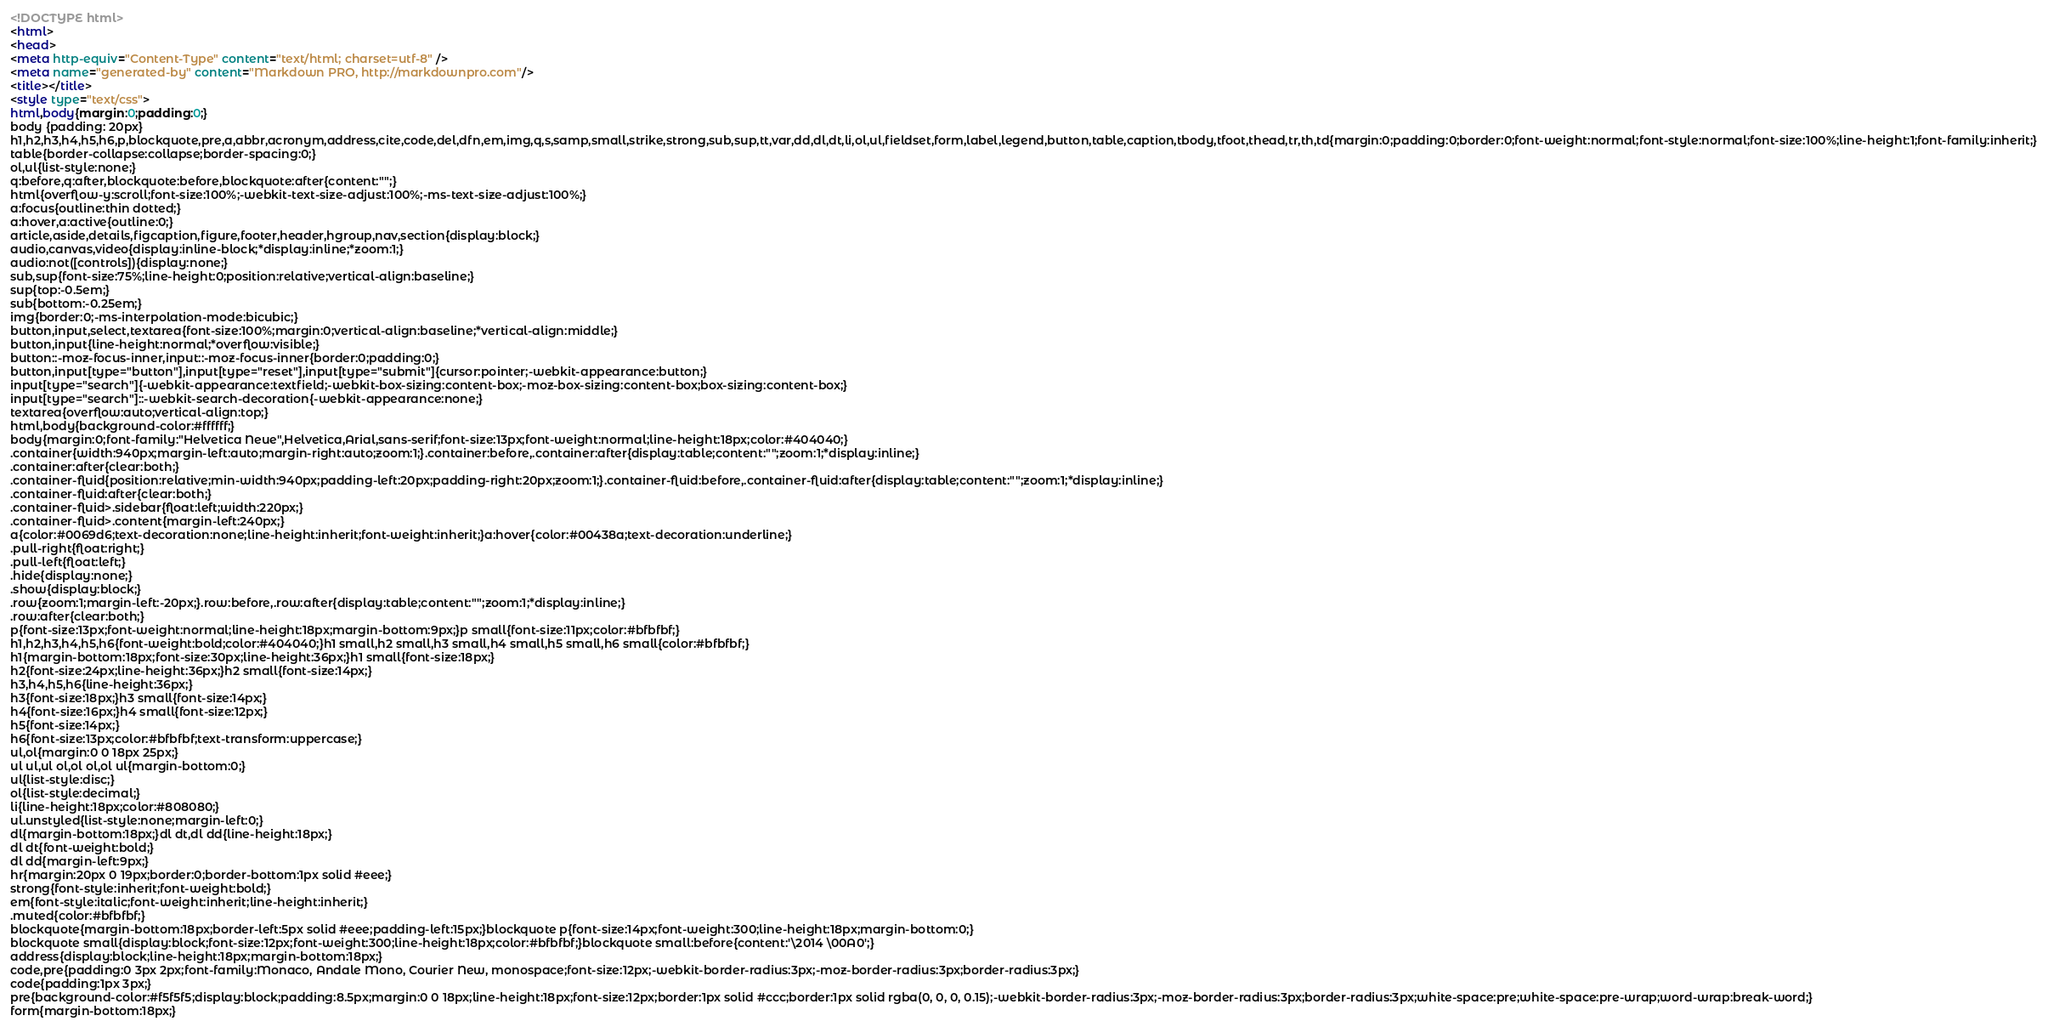Convert code to text. <code><loc_0><loc_0><loc_500><loc_500><_HTML_><!DOCTYPE html>
<html>
<head>
<meta http-equiv="Content-Type" content="text/html; charset=utf-8" />
<meta name="generated-by" content="Markdown PRO, http://markdownpro.com"/>
<title></title>
<style type="text/css">
html,body{margin:0;padding:0;}
body {padding: 20px}
h1,h2,h3,h4,h5,h6,p,blockquote,pre,a,abbr,acronym,address,cite,code,del,dfn,em,img,q,s,samp,small,strike,strong,sub,sup,tt,var,dd,dl,dt,li,ol,ul,fieldset,form,label,legend,button,table,caption,tbody,tfoot,thead,tr,th,td{margin:0;padding:0;border:0;font-weight:normal;font-style:normal;font-size:100%;line-height:1;font-family:inherit;}
table{border-collapse:collapse;border-spacing:0;}
ol,ul{list-style:none;}
q:before,q:after,blockquote:before,blockquote:after{content:"";}
html{overflow-y:scroll;font-size:100%;-webkit-text-size-adjust:100%;-ms-text-size-adjust:100%;}
a:focus{outline:thin dotted;}
a:hover,a:active{outline:0;}
article,aside,details,figcaption,figure,footer,header,hgroup,nav,section{display:block;}
audio,canvas,video{display:inline-block;*display:inline;*zoom:1;}
audio:not([controls]){display:none;}
sub,sup{font-size:75%;line-height:0;position:relative;vertical-align:baseline;}
sup{top:-0.5em;}
sub{bottom:-0.25em;}
img{border:0;-ms-interpolation-mode:bicubic;}
button,input,select,textarea{font-size:100%;margin:0;vertical-align:baseline;*vertical-align:middle;}
button,input{line-height:normal;*overflow:visible;}
button::-moz-focus-inner,input::-moz-focus-inner{border:0;padding:0;}
button,input[type="button"],input[type="reset"],input[type="submit"]{cursor:pointer;-webkit-appearance:button;}
input[type="search"]{-webkit-appearance:textfield;-webkit-box-sizing:content-box;-moz-box-sizing:content-box;box-sizing:content-box;}
input[type="search"]::-webkit-search-decoration{-webkit-appearance:none;}
textarea{overflow:auto;vertical-align:top;}
html,body{background-color:#ffffff;}
body{margin:0;font-family:"Helvetica Neue",Helvetica,Arial,sans-serif;font-size:13px;font-weight:normal;line-height:18px;color:#404040;}
.container{width:940px;margin-left:auto;margin-right:auto;zoom:1;}.container:before,.container:after{display:table;content:"";zoom:1;*display:inline;}
.container:after{clear:both;}
.container-fluid{position:relative;min-width:940px;padding-left:20px;padding-right:20px;zoom:1;}.container-fluid:before,.container-fluid:after{display:table;content:"";zoom:1;*display:inline;}
.container-fluid:after{clear:both;}
.container-fluid>.sidebar{float:left;width:220px;}
.container-fluid>.content{margin-left:240px;}
a{color:#0069d6;text-decoration:none;line-height:inherit;font-weight:inherit;}a:hover{color:#00438a;text-decoration:underline;}
.pull-right{float:right;}
.pull-left{float:left;}
.hide{display:none;}
.show{display:block;}
.row{zoom:1;margin-left:-20px;}.row:before,.row:after{display:table;content:"";zoom:1;*display:inline;}
.row:after{clear:both;}
p{font-size:13px;font-weight:normal;line-height:18px;margin-bottom:9px;}p small{font-size:11px;color:#bfbfbf;}
h1,h2,h3,h4,h5,h6{font-weight:bold;color:#404040;}h1 small,h2 small,h3 small,h4 small,h5 small,h6 small{color:#bfbfbf;}
h1{margin-bottom:18px;font-size:30px;line-height:36px;}h1 small{font-size:18px;}
h2{font-size:24px;line-height:36px;}h2 small{font-size:14px;}
h3,h4,h5,h6{line-height:36px;}
h3{font-size:18px;}h3 small{font-size:14px;}
h4{font-size:16px;}h4 small{font-size:12px;}
h5{font-size:14px;}
h6{font-size:13px;color:#bfbfbf;text-transform:uppercase;}
ul,ol{margin:0 0 18px 25px;}
ul ul,ul ol,ol ol,ol ul{margin-bottom:0;}
ul{list-style:disc;}
ol{list-style:decimal;}
li{line-height:18px;color:#808080;}
ul.unstyled{list-style:none;margin-left:0;}
dl{margin-bottom:18px;}dl dt,dl dd{line-height:18px;}
dl dt{font-weight:bold;}
dl dd{margin-left:9px;}
hr{margin:20px 0 19px;border:0;border-bottom:1px solid #eee;}
strong{font-style:inherit;font-weight:bold;}
em{font-style:italic;font-weight:inherit;line-height:inherit;}
.muted{color:#bfbfbf;}
blockquote{margin-bottom:18px;border-left:5px solid #eee;padding-left:15px;}blockquote p{font-size:14px;font-weight:300;line-height:18px;margin-bottom:0;}
blockquote small{display:block;font-size:12px;font-weight:300;line-height:18px;color:#bfbfbf;}blockquote small:before{content:'\2014 \00A0';}
address{display:block;line-height:18px;margin-bottom:18px;}
code,pre{padding:0 3px 2px;font-family:Monaco, Andale Mono, Courier New, monospace;font-size:12px;-webkit-border-radius:3px;-moz-border-radius:3px;border-radius:3px;}
code{padding:1px 3px;}
pre{background-color:#f5f5f5;display:block;padding:8.5px;margin:0 0 18px;line-height:18px;font-size:12px;border:1px solid #ccc;border:1px solid rgba(0, 0, 0, 0.15);-webkit-border-radius:3px;-moz-border-radius:3px;border-radius:3px;white-space:pre;white-space:pre-wrap;word-wrap:break-word;}
form{margin-bottom:18px;}</code> 